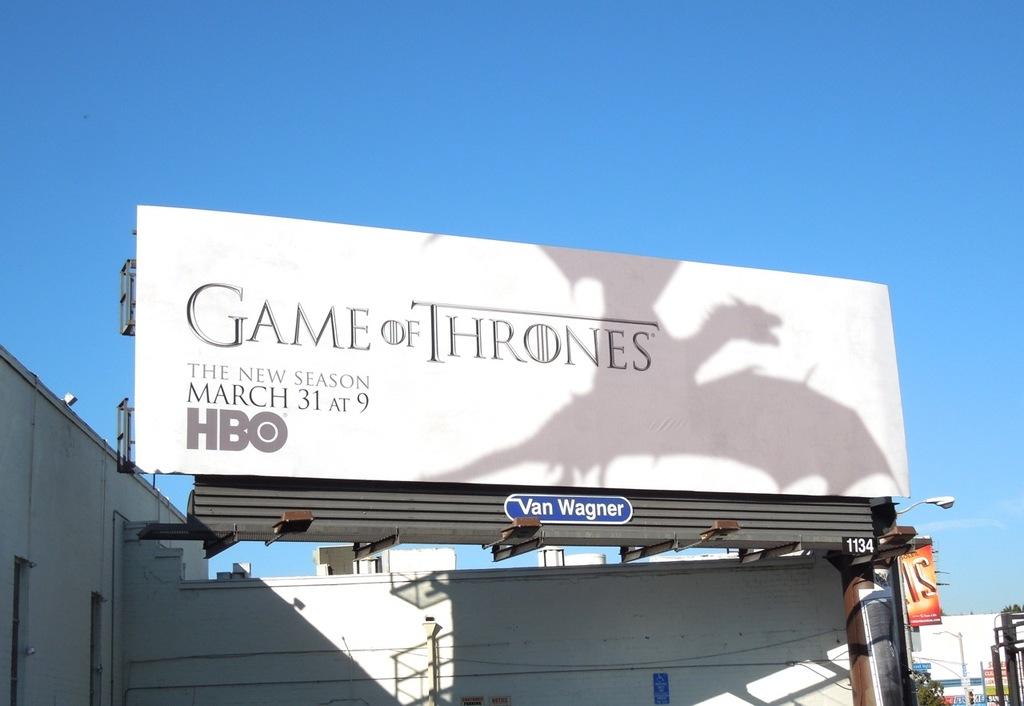When does "game of thrones" start on hbo?
Offer a terse response. March 31. What company owns this billboard?
Keep it short and to the point. Van wagner. 